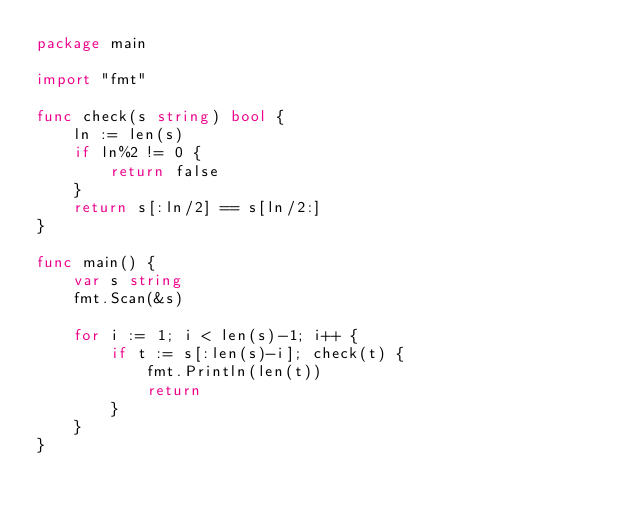Convert code to text. <code><loc_0><loc_0><loc_500><loc_500><_Go_>package main

import "fmt"

func check(s string) bool {
	ln := len(s)
	if ln%2 != 0 {
		return false
	}
	return s[:ln/2] == s[ln/2:]
}

func main() {
	var s string
	fmt.Scan(&s)

	for i := 1; i < len(s)-1; i++ {
		if t := s[:len(s)-i]; check(t) {
			fmt.Println(len(t))
			return
		}
	}
}
</code> 